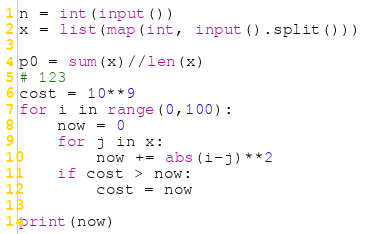Convert code to text. <code><loc_0><loc_0><loc_500><loc_500><_Python_>n = int(input())
x = list(map(int, input().split()))

p0 = sum(x)//len(x)
# 123
cost = 10**9
for i in range(0,100):
    now = 0
    for j in x:
        now += abs(i-j)**2
    if cost > now:
        cost = now

print(now)
</code> 